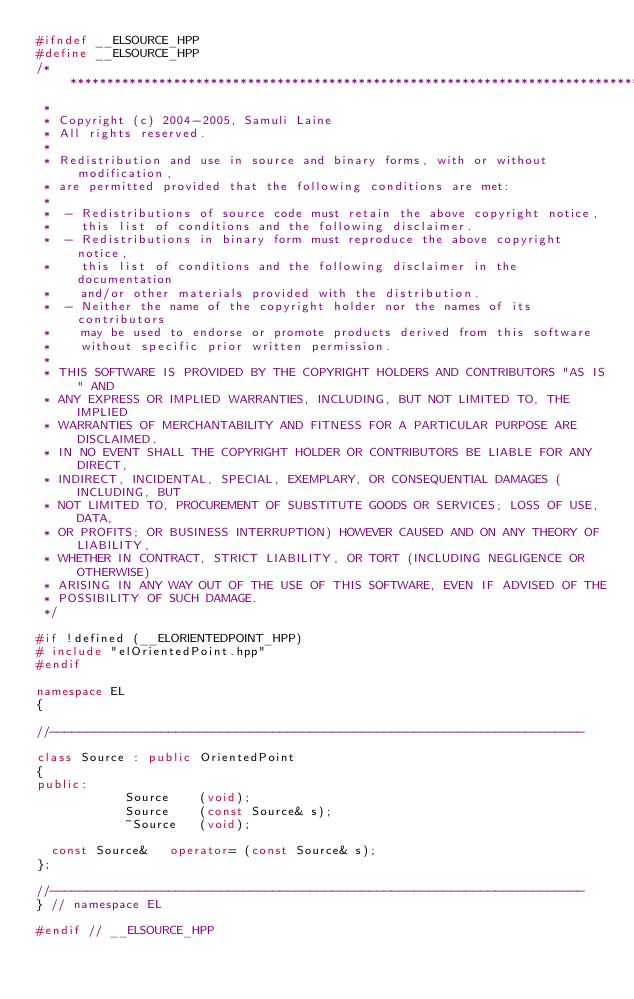Convert code to text. <code><loc_0><loc_0><loc_500><loc_500><_C++_>#ifndef __ELSOURCE_HPP
#define __ELSOURCE_HPP
/******************************************************************************
 *
 * Copyright (c) 2004-2005, Samuli Laine
 * All rights reserved.
 *
 * Redistribution and use in source and binary forms, with or without modification,
 * are permitted provided that the following conditions are met:
 *
 *  - Redistributions of source code must retain the above copyright notice,
 *    this list of conditions and the following disclaimer.
 *  - Redistributions in binary form must reproduce the above copyright notice,
 *    this list of conditions and the following disclaimer in the documentation
 *    and/or other materials provided with the distribution.
 *  - Neither the name of the copyright holder nor the names of its contributors
 *    may be used to endorse or promote products derived from this software
 *    without specific prior written permission.
 *
 * THIS SOFTWARE IS PROVIDED BY THE COPYRIGHT HOLDERS AND CONTRIBUTORS "AS IS" AND
 * ANY EXPRESS OR IMPLIED WARRANTIES, INCLUDING, BUT NOT LIMITED TO, THE IMPLIED
 * WARRANTIES OF MERCHANTABILITY AND FITNESS FOR A PARTICULAR PURPOSE ARE DISCLAIMED.
 * IN NO EVENT SHALL THE COPYRIGHT HOLDER OR CONTRIBUTORS BE LIABLE FOR ANY DIRECT,
 * INDIRECT, INCIDENTAL, SPECIAL, EXEMPLARY, OR CONSEQUENTIAL DAMAGES (INCLUDING, BUT
 * NOT LIMITED TO, PROCUREMENT OF SUBSTITUTE GOODS OR SERVICES; LOSS OF USE, DATA,
 * OR PROFITS; OR BUSINESS INTERRUPTION) HOWEVER CAUSED AND ON ANY THEORY OF LIABILITY,
 * WHETHER IN CONTRACT, STRICT LIABILITY, OR TORT (INCLUDING NEGLIGENCE OR OTHERWISE)
 * ARISING IN ANY WAY OUT OF THE USE OF THIS SOFTWARE, EVEN IF ADVISED OF THE
 * POSSIBILITY OF SUCH DAMAGE.
 */

#if !defined (__ELORIENTEDPOINT_HPP)
#	include "elOrientedPoint.hpp"
#endif

namespace EL
{

//------------------------------------------------------------------------

class Source : public OrientedPoint
{
public:
						Source		(void);
						Source		(const Source& s);
						~Source		(void);

	const Source&		operator=	(const Source& s);
};

//------------------------------------------------------------------------
} // namespace EL

#endif // __ELSOURCE_HPP
</code> 